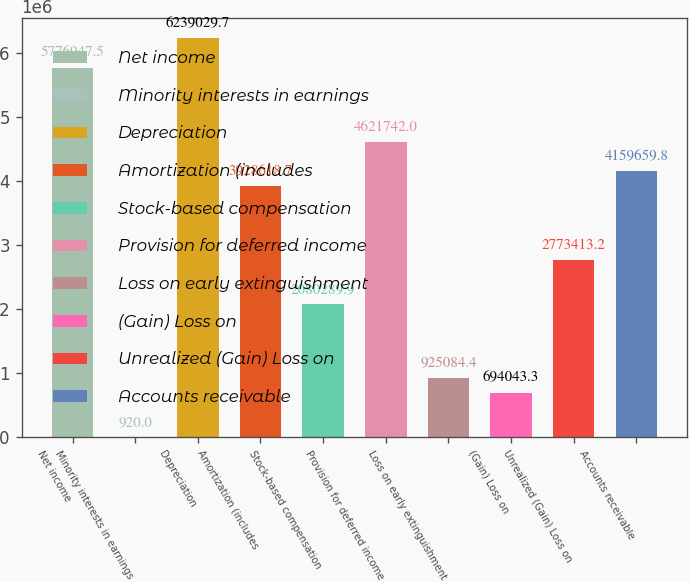Convert chart. <chart><loc_0><loc_0><loc_500><loc_500><bar_chart><fcel>Net income<fcel>Minority interests in earnings<fcel>Depreciation<fcel>Amortization (includes<fcel>Stock-based compensation<fcel>Provision for deferred income<fcel>Loss on early extinguishment<fcel>(Gain) Loss on<fcel>Unrealized (Gain) Loss on<fcel>Accounts receivable<nl><fcel>5.77695e+06<fcel>920<fcel>6.23903e+06<fcel>3.92862e+06<fcel>2.08029e+06<fcel>4.62174e+06<fcel>925084<fcel>694043<fcel>2.77341e+06<fcel>4.15966e+06<nl></chart> 